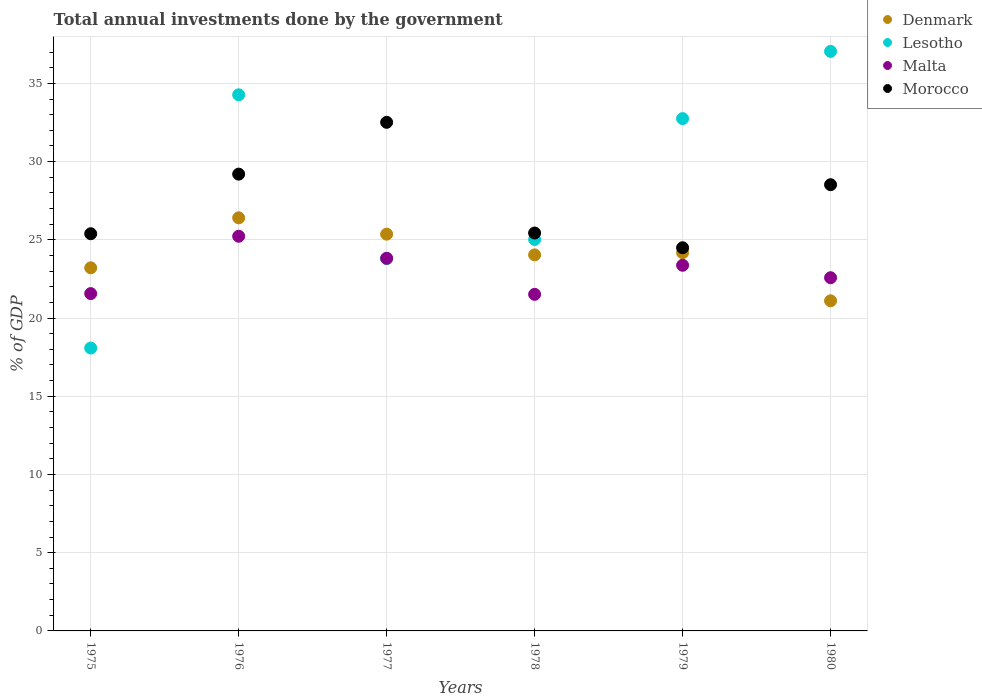What is the total annual investments done by the government in Malta in 1978?
Ensure brevity in your answer.  21.51. Across all years, what is the maximum total annual investments done by the government in Malta?
Provide a succinct answer. 25.23. Across all years, what is the minimum total annual investments done by the government in Malta?
Keep it short and to the point. 21.51. In which year was the total annual investments done by the government in Denmark maximum?
Your answer should be compact. 1976. In which year was the total annual investments done by the government in Lesotho minimum?
Your response must be concise. 1975. What is the total total annual investments done by the government in Morocco in the graph?
Ensure brevity in your answer.  165.54. What is the difference between the total annual investments done by the government in Malta in 1976 and that in 1980?
Ensure brevity in your answer.  2.65. What is the difference between the total annual investments done by the government in Lesotho in 1978 and the total annual investments done by the government in Morocco in 1976?
Give a very brief answer. -4.18. What is the average total annual investments done by the government in Lesotho per year?
Make the answer very short. 28.49. In the year 1978, what is the difference between the total annual investments done by the government in Denmark and total annual investments done by the government in Malta?
Provide a short and direct response. 2.52. What is the ratio of the total annual investments done by the government in Lesotho in 1975 to that in 1980?
Offer a terse response. 0.49. What is the difference between the highest and the second highest total annual investments done by the government in Morocco?
Provide a succinct answer. 3.31. What is the difference between the highest and the lowest total annual investments done by the government in Lesotho?
Provide a short and direct response. 18.96. Is the sum of the total annual investments done by the government in Malta in 1976 and 1979 greater than the maximum total annual investments done by the government in Lesotho across all years?
Your response must be concise. Yes. Is it the case that in every year, the sum of the total annual investments done by the government in Lesotho and total annual investments done by the government in Denmark  is greater than the total annual investments done by the government in Morocco?
Give a very brief answer. Yes. Does the total annual investments done by the government in Morocco monotonically increase over the years?
Give a very brief answer. No. Is the total annual investments done by the government in Lesotho strictly less than the total annual investments done by the government in Morocco over the years?
Ensure brevity in your answer.  No. How many dotlines are there?
Keep it short and to the point. 4. What is the difference between two consecutive major ticks on the Y-axis?
Ensure brevity in your answer.  5. Are the values on the major ticks of Y-axis written in scientific E-notation?
Ensure brevity in your answer.  No. Does the graph contain any zero values?
Your answer should be compact. No. Does the graph contain grids?
Your answer should be compact. Yes. How many legend labels are there?
Offer a very short reply. 4. What is the title of the graph?
Keep it short and to the point. Total annual investments done by the government. What is the label or title of the Y-axis?
Your response must be concise. % of GDP. What is the % of GDP of Denmark in 1975?
Provide a short and direct response. 23.21. What is the % of GDP of Lesotho in 1975?
Give a very brief answer. 18.08. What is the % of GDP of Malta in 1975?
Your response must be concise. 21.56. What is the % of GDP in Morocco in 1975?
Give a very brief answer. 25.39. What is the % of GDP of Denmark in 1976?
Offer a very short reply. 26.41. What is the % of GDP of Lesotho in 1976?
Provide a short and direct response. 34.27. What is the % of GDP in Malta in 1976?
Offer a terse response. 25.23. What is the % of GDP in Morocco in 1976?
Your response must be concise. 29.2. What is the % of GDP of Denmark in 1977?
Ensure brevity in your answer.  25.36. What is the % of GDP in Lesotho in 1977?
Offer a terse response. 23.8. What is the % of GDP in Malta in 1977?
Your response must be concise. 23.82. What is the % of GDP of Morocco in 1977?
Your response must be concise. 32.51. What is the % of GDP of Denmark in 1978?
Give a very brief answer. 24.04. What is the % of GDP of Lesotho in 1978?
Your answer should be compact. 25.02. What is the % of GDP of Malta in 1978?
Keep it short and to the point. 21.51. What is the % of GDP in Morocco in 1978?
Make the answer very short. 25.43. What is the % of GDP in Denmark in 1979?
Keep it short and to the point. 24.18. What is the % of GDP in Lesotho in 1979?
Make the answer very short. 32.75. What is the % of GDP of Malta in 1979?
Your answer should be compact. 23.37. What is the % of GDP of Morocco in 1979?
Offer a terse response. 24.49. What is the % of GDP in Denmark in 1980?
Keep it short and to the point. 21.1. What is the % of GDP in Lesotho in 1980?
Your answer should be compact. 37.04. What is the % of GDP of Malta in 1980?
Provide a short and direct response. 22.58. What is the % of GDP in Morocco in 1980?
Offer a terse response. 28.52. Across all years, what is the maximum % of GDP in Denmark?
Provide a succinct answer. 26.41. Across all years, what is the maximum % of GDP in Lesotho?
Your answer should be compact. 37.04. Across all years, what is the maximum % of GDP in Malta?
Keep it short and to the point. 25.23. Across all years, what is the maximum % of GDP in Morocco?
Your answer should be very brief. 32.51. Across all years, what is the minimum % of GDP of Denmark?
Offer a terse response. 21.1. Across all years, what is the minimum % of GDP of Lesotho?
Keep it short and to the point. 18.08. Across all years, what is the minimum % of GDP in Malta?
Keep it short and to the point. 21.51. Across all years, what is the minimum % of GDP of Morocco?
Keep it short and to the point. 24.49. What is the total % of GDP in Denmark in the graph?
Provide a succinct answer. 144.29. What is the total % of GDP in Lesotho in the graph?
Give a very brief answer. 170.96. What is the total % of GDP in Malta in the graph?
Your answer should be very brief. 138.07. What is the total % of GDP of Morocco in the graph?
Provide a succinct answer. 165.54. What is the difference between the % of GDP of Denmark in 1975 and that in 1976?
Ensure brevity in your answer.  -3.2. What is the difference between the % of GDP of Lesotho in 1975 and that in 1976?
Provide a short and direct response. -16.18. What is the difference between the % of GDP of Malta in 1975 and that in 1976?
Make the answer very short. -3.67. What is the difference between the % of GDP of Morocco in 1975 and that in 1976?
Your answer should be very brief. -3.81. What is the difference between the % of GDP of Denmark in 1975 and that in 1977?
Offer a terse response. -2.15. What is the difference between the % of GDP of Lesotho in 1975 and that in 1977?
Your answer should be compact. -5.71. What is the difference between the % of GDP in Malta in 1975 and that in 1977?
Ensure brevity in your answer.  -2.26. What is the difference between the % of GDP in Morocco in 1975 and that in 1977?
Keep it short and to the point. -7.12. What is the difference between the % of GDP in Denmark in 1975 and that in 1978?
Your response must be concise. -0.83. What is the difference between the % of GDP of Lesotho in 1975 and that in 1978?
Your answer should be very brief. -6.94. What is the difference between the % of GDP of Malta in 1975 and that in 1978?
Ensure brevity in your answer.  0.05. What is the difference between the % of GDP of Morocco in 1975 and that in 1978?
Your answer should be very brief. -0.05. What is the difference between the % of GDP of Denmark in 1975 and that in 1979?
Give a very brief answer. -0.97. What is the difference between the % of GDP of Lesotho in 1975 and that in 1979?
Your response must be concise. -14.66. What is the difference between the % of GDP in Malta in 1975 and that in 1979?
Offer a terse response. -1.81. What is the difference between the % of GDP in Morocco in 1975 and that in 1979?
Make the answer very short. 0.9. What is the difference between the % of GDP in Denmark in 1975 and that in 1980?
Offer a very short reply. 2.11. What is the difference between the % of GDP of Lesotho in 1975 and that in 1980?
Ensure brevity in your answer.  -18.96. What is the difference between the % of GDP in Malta in 1975 and that in 1980?
Offer a very short reply. -1.01. What is the difference between the % of GDP of Morocco in 1975 and that in 1980?
Provide a succinct answer. -3.13. What is the difference between the % of GDP in Denmark in 1976 and that in 1977?
Provide a short and direct response. 1.04. What is the difference between the % of GDP in Lesotho in 1976 and that in 1977?
Provide a short and direct response. 10.47. What is the difference between the % of GDP in Malta in 1976 and that in 1977?
Your answer should be very brief. 1.41. What is the difference between the % of GDP in Morocco in 1976 and that in 1977?
Provide a short and direct response. -3.31. What is the difference between the % of GDP of Denmark in 1976 and that in 1978?
Provide a short and direct response. 2.37. What is the difference between the % of GDP in Lesotho in 1976 and that in 1978?
Provide a succinct answer. 9.25. What is the difference between the % of GDP in Malta in 1976 and that in 1978?
Offer a very short reply. 3.71. What is the difference between the % of GDP in Morocco in 1976 and that in 1978?
Provide a short and direct response. 3.76. What is the difference between the % of GDP of Denmark in 1976 and that in 1979?
Make the answer very short. 2.23. What is the difference between the % of GDP in Lesotho in 1976 and that in 1979?
Give a very brief answer. 1.52. What is the difference between the % of GDP of Malta in 1976 and that in 1979?
Your answer should be compact. 1.86. What is the difference between the % of GDP of Morocco in 1976 and that in 1979?
Your response must be concise. 4.71. What is the difference between the % of GDP of Denmark in 1976 and that in 1980?
Make the answer very short. 5.3. What is the difference between the % of GDP in Lesotho in 1976 and that in 1980?
Keep it short and to the point. -2.77. What is the difference between the % of GDP in Malta in 1976 and that in 1980?
Give a very brief answer. 2.65. What is the difference between the % of GDP in Morocco in 1976 and that in 1980?
Your response must be concise. 0.68. What is the difference between the % of GDP of Denmark in 1977 and that in 1978?
Offer a very short reply. 1.33. What is the difference between the % of GDP in Lesotho in 1977 and that in 1978?
Make the answer very short. -1.23. What is the difference between the % of GDP in Malta in 1977 and that in 1978?
Ensure brevity in your answer.  2.31. What is the difference between the % of GDP in Morocco in 1977 and that in 1978?
Your answer should be compact. 7.08. What is the difference between the % of GDP of Denmark in 1977 and that in 1979?
Offer a very short reply. 1.19. What is the difference between the % of GDP of Lesotho in 1977 and that in 1979?
Make the answer very short. -8.95. What is the difference between the % of GDP of Malta in 1977 and that in 1979?
Your response must be concise. 0.45. What is the difference between the % of GDP of Morocco in 1977 and that in 1979?
Your answer should be very brief. 8.02. What is the difference between the % of GDP in Denmark in 1977 and that in 1980?
Offer a terse response. 4.26. What is the difference between the % of GDP of Lesotho in 1977 and that in 1980?
Your answer should be very brief. -13.25. What is the difference between the % of GDP in Malta in 1977 and that in 1980?
Provide a succinct answer. 1.24. What is the difference between the % of GDP of Morocco in 1977 and that in 1980?
Give a very brief answer. 3.99. What is the difference between the % of GDP in Denmark in 1978 and that in 1979?
Your response must be concise. -0.14. What is the difference between the % of GDP in Lesotho in 1978 and that in 1979?
Offer a terse response. -7.73. What is the difference between the % of GDP of Malta in 1978 and that in 1979?
Offer a very short reply. -1.86. What is the difference between the % of GDP in Morocco in 1978 and that in 1979?
Ensure brevity in your answer.  0.94. What is the difference between the % of GDP in Denmark in 1978 and that in 1980?
Your answer should be very brief. 2.94. What is the difference between the % of GDP of Lesotho in 1978 and that in 1980?
Your answer should be compact. -12.02. What is the difference between the % of GDP of Malta in 1978 and that in 1980?
Your response must be concise. -1.06. What is the difference between the % of GDP in Morocco in 1978 and that in 1980?
Provide a short and direct response. -3.09. What is the difference between the % of GDP in Denmark in 1979 and that in 1980?
Your answer should be compact. 3.08. What is the difference between the % of GDP of Lesotho in 1979 and that in 1980?
Your response must be concise. -4.3. What is the difference between the % of GDP in Malta in 1979 and that in 1980?
Your response must be concise. 0.79. What is the difference between the % of GDP in Morocco in 1979 and that in 1980?
Make the answer very short. -4.03. What is the difference between the % of GDP of Denmark in 1975 and the % of GDP of Lesotho in 1976?
Give a very brief answer. -11.06. What is the difference between the % of GDP of Denmark in 1975 and the % of GDP of Malta in 1976?
Offer a very short reply. -2.02. What is the difference between the % of GDP in Denmark in 1975 and the % of GDP in Morocco in 1976?
Ensure brevity in your answer.  -5.99. What is the difference between the % of GDP in Lesotho in 1975 and the % of GDP in Malta in 1976?
Your response must be concise. -7.14. What is the difference between the % of GDP of Lesotho in 1975 and the % of GDP of Morocco in 1976?
Your answer should be very brief. -11.11. What is the difference between the % of GDP in Malta in 1975 and the % of GDP in Morocco in 1976?
Your answer should be very brief. -7.64. What is the difference between the % of GDP in Denmark in 1975 and the % of GDP in Lesotho in 1977?
Provide a succinct answer. -0.59. What is the difference between the % of GDP in Denmark in 1975 and the % of GDP in Malta in 1977?
Ensure brevity in your answer.  -0.61. What is the difference between the % of GDP of Denmark in 1975 and the % of GDP of Morocco in 1977?
Your answer should be compact. -9.3. What is the difference between the % of GDP in Lesotho in 1975 and the % of GDP in Malta in 1977?
Give a very brief answer. -5.74. What is the difference between the % of GDP of Lesotho in 1975 and the % of GDP of Morocco in 1977?
Provide a short and direct response. -14.43. What is the difference between the % of GDP in Malta in 1975 and the % of GDP in Morocco in 1977?
Ensure brevity in your answer.  -10.95. What is the difference between the % of GDP of Denmark in 1975 and the % of GDP of Lesotho in 1978?
Provide a short and direct response. -1.81. What is the difference between the % of GDP of Denmark in 1975 and the % of GDP of Malta in 1978?
Provide a succinct answer. 1.69. What is the difference between the % of GDP in Denmark in 1975 and the % of GDP in Morocco in 1978?
Give a very brief answer. -2.22. What is the difference between the % of GDP of Lesotho in 1975 and the % of GDP of Malta in 1978?
Give a very brief answer. -3.43. What is the difference between the % of GDP in Lesotho in 1975 and the % of GDP in Morocco in 1978?
Provide a succinct answer. -7.35. What is the difference between the % of GDP of Malta in 1975 and the % of GDP of Morocco in 1978?
Provide a short and direct response. -3.87. What is the difference between the % of GDP of Denmark in 1975 and the % of GDP of Lesotho in 1979?
Your answer should be compact. -9.54. What is the difference between the % of GDP of Denmark in 1975 and the % of GDP of Malta in 1979?
Your answer should be very brief. -0.16. What is the difference between the % of GDP in Denmark in 1975 and the % of GDP in Morocco in 1979?
Give a very brief answer. -1.28. What is the difference between the % of GDP in Lesotho in 1975 and the % of GDP in Malta in 1979?
Make the answer very short. -5.29. What is the difference between the % of GDP of Lesotho in 1975 and the % of GDP of Morocco in 1979?
Offer a terse response. -6.41. What is the difference between the % of GDP of Malta in 1975 and the % of GDP of Morocco in 1979?
Your response must be concise. -2.93. What is the difference between the % of GDP in Denmark in 1975 and the % of GDP in Lesotho in 1980?
Your response must be concise. -13.83. What is the difference between the % of GDP of Denmark in 1975 and the % of GDP of Malta in 1980?
Keep it short and to the point. 0.63. What is the difference between the % of GDP in Denmark in 1975 and the % of GDP in Morocco in 1980?
Offer a very short reply. -5.31. What is the difference between the % of GDP of Lesotho in 1975 and the % of GDP of Malta in 1980?
Your answer should be very brief. -4.49. What is the difference between the % of GDP of Lesotho in 1975 and the % of GDP of Morocco in 1980?
Make the answer very short. -10.44. What is the difference between the % of GDP in Malta in 1975 and the % of GDP in Morocco in 1980?
Your answer should be compact. -6.96. What is the difference between the % of GDP in Denmark in 1976 and the % of GDP in Lesotho in 1977?
Provide a succinct answer. 2.61. What is the difference between the % of GDP in Denmark in 1976 and the % of GDP in Malta in 1977?
Your response must be concise. 2.59. What is the difference between the % of GDP in Denmark in 1976 and the % of GDP in Morocco in 1977?
Provide a succinct answer. -6.1. What is the difference between the % of GDP in Lesotho in 1976 and the % of GDP in Malta in 1977?
Your response must be concise. 10.45. What is the difference between the % of GDP of Lesotho in 1976 and the % of GDP of Morocco in 1977?
Provide a succinct answer. 1.76. What is the difference between the % of GDP of Malta in 1976 and the % of GDP of Morocco in 1977?
Ensure brevity in your answer.  -7.28. What is the difference between the % of GDP of Denmark in 1976 and the % of GDP of Lesotho in 1978?
Your answer should be compact. 1.38. What is the difference between the % of GDP in Denmark in 1976 and the % of GDP in Malta in 1978?
Your answer should be very brief. 4.89. What is the difference between the % of GDP of Denmark in 1976 and the % of GDP of Morocco in 1978?
Offer a very short reply. 0.97. What is the difference between the % of GDP in Lesotho in 1976 and the % of GDP in Malta in 1978?
Offer a very short reply. 12.75. What is the difference between the % of GDP of Lesotho in 1976 and the % of GDP of Morocco in 1978?
Keep it short and to the point. 8.83. What is the difference between the % of GDP in Malta in 1976 and the % of GDP in Morocco in 1978?
Provide a succinct answer. -0.21. What is the difference between the % of GDP of Denmark in 1976 and the % of GDP of Lesotho in 1979?
Keep it short and to the point. -6.34. What is the difference between the % of GDP in Denmark in 1976 and the % of GDP in Malta in 1979?
Provide a short and direct response. 3.03. What is the difference between the % of GDP of Denmark in 1976 and the % of GDP of Morocco in 1979?
Provide a short and direct response. 1.91. What is the difference between the % of GDP in Lesotho in 1976 and the % of GDP in Malta in 1979?
Your response must be concise. 10.9. What is the difference between the % of GDP of Lesotho in 1976 and the % of GDP of Morocco in 1979?
Your answer should be compact. 9.78. What is the difference between the % of GDP of Malta in 1976 and the % of GDP of Morocco in 1979?
Offer a terse response. 0.74. What is the difference between the % of GDP in Denmark in 1976 and the % of GDP in Lesotho in 1980?
Provide a succinct answer. -10.64. What is the difference between the % of GDP of Denmark in 1976 and the % of GDP of Malta in 1980?
Your response must be concise. 3.83. What is the difference between the % of GDP in Denmark in 1976 and the % of GDP in Morocco in 1980?
Provide a succinct answer. -2.12. What is the difference between the % of GDP of Lesotho in 1976 and the % of GDP of Malta in 1980?
Provide a succinct answer. 11.69. What is the difference between the % of GDP of Lesotho in 1976 and the % of GDP of Morocco in 1980?
Make the answer very short. 5.75. What is the difference between the % of GDP in Malta in 1976 and the % of GDP in Morocco in 1980?
Provide a short and direct response. -3.29. What is the difference between the % of GDP of Denmark in 1977 and the % of GDP of Lesotho in 1978?
Your answer should be very brief. 0.34. What is the difference between the % of GDP in Denmark in 1977 and the % of GDP in Malta in 1978?
Keep it short and to the point. 3.85. What is the difference between the % of GDP of Denmark in 1977 and the % of GDP of Morocco in 1978?
Ensure brevity in your answer.  -0.07. What is the difference between the % of GDP of Lesotho in 1977 and the % of GDP of Malta in 1978?
Your answer should be very brief. 2.28. What is the difference between the % of GDP in Lesotho in 1977 and the % of GDP in Morocco in 1978?
Your answer should be compact. -1.64. What is the difference between the % of GDP in Malta in 1977 and the % of GDP in Morocco in 1978?
Offer a terse response. -1.61. What is the difference between the % of GDP of Denmark in 1977 and the % of GDP of Lesotho in 1979?
Your response must be concise. -7.38. What is the difference between the % of GDP in Denmark in 1977 and the % of GDP in Malta in 1979?
Give a very brief answer. 1.99. What is the difference between the % of GDP of Denmark in 1977 and the % of GDP of Morocco in 1979?
Give a very brief answer. 0.87. What is the difference between the % of GDP in Lesotho in 1977 and the % of GDP in Malta in 1979?
Make the answer very short. 0.42. What is the difference between the % of GDP of Lesotho in 1977 and the % of GDP of Morocco in 1979?
Provide a succinct answer. -0.7. What is the difference between the % of GDP in Malta in 1977 and the % of GDP in Morocco in 1979?
Keep it short and to the point. -0.67. What is the difference between the % of GDP of Denmark in 1977 and the % of GDP of Lesotho in 1980?
Offer a terse response. -11.68. What is the difference between the % of GDP of Denmark in 1977 and the % of GDP of Malta in 1980?
Provide a succinct answer. 2.79. What is the difference between the % of GDP of Denmark in 1977 and the % of GDP of Morocco in 1980?
Your response must be concise. -3.16. What is the difference between the % of GDP of Lesotho in 1977 and the % of GDP of Malta in 1980?
Offer a terse response. 1.22. What is the difference between the % of GDP of Lesotho in 1977 and the % of GDP of Morocco in 1980?
Provide a short and direct response. -4.73. What is the difference between the % of GDP of Malta in 1977 and the % of GDP of Morocco in 1980?
Your answer should be very brief. -4.7. What is the difference between the % of GDP in Denmark in 1978 and the % of GDP in Lesotho in 1979?
Keep it short and to the point. -8.71. What is the difference between the % of GDP of Denmark in 1978 and the % of GDP of Malta in 1979?
Provide a short and direct response. 0.66. What is the difference between the % of GDP in Denmark in 1978 and the % of GDP in Morocco in 1979?
Provide a short and direct response. -0.46. What is the difference between the % of GDP in Lesotho in 1978 and the % of GDP in Malta in 1979?
Ensure brevity in your answer.  1.65. What is the difference between the % of GDP of Lesotho in 1978 and the % of GDP of Morocco in 1979?
Your answer should be compact. 0.53. What is the difference between the % of GDP in Malta in 1978 and the % of GDP in Morocco in 1979?
Your answer should be compact. -2.98. What is the difference between the % of GDP in Denmark in 1978 and the % of GDP in Lesotho in 1980?
Give a very brief answer. -13.01. What is the difference between the % of GDP of Denmark in 1978 and the % of GDP of Malta in 1980?
Your answer should be compact. 1.46. What is the difference between the % of GDP in Denmark in 1978 and the % of GDP in Morocco in 1980?
Offer a very short reply. -4.49. What is the difference between the % of GDP of Lesotho in 1978 and the % of GDP of Malta in 1980?
Provide a succinct answer. 2.44. What is the difference between the % of GDP in Lesotho in 1978 and the % of GDP in Morocco in 1980?
Your answer should be compact. -3.5. What is the difference between the % of GDP of Malta in 1978 and the % of GDP of Morocco in 1980?
Make the answer very short. -7.01. What is the difference between the % of GDP of Denmark in 1979 and the % of GDP of Lesotho in 1980?
Your answer should be compact. -12.87. What is the difference between the % of GDP of Denmark in 1979 and the % of GDP of Malta in 1980?
Make the answer very short. 1.6. What is the difference between the % of GDP in Denmark in 1979 and the % of GDP in Morocco in 1980?
Your answer should be very brief. -4.35. What is the difference between the % of GDP of Lesotho in 1979 and the % of GDP of Malta in 1980?
Provide a short and direct response. 10.17. What is the difference between the % of GDP of Lesotho in 1979 and the % of GDP of Morocco in 1980?
Your response must be concise. 4.22. What is the difference between the % of GDP in Malta in 1979 and the % of GDP in Morocco in 1980?
Keep it short and to the point. -5.15. What is the average % of GDP in Denmark per year?
Keep it short and to the point. 24.05. What is the average % of GDP of Lesotho per year?
Your answer should be very brief. 28.49. What is the average % of GDP in Malta per year?
Offer a very short reply. 23.01. What is the average % of GDP in Morocco per year?
Make the answer very short. 27.59. In the year 1975, what is the difference between the % of GDP of Denmark and % of GDP of Lesotho?
Your response must be concise. 5.13. In the year 1975, what is the difference between the % of GDP of Denmark and % of GDP of Malta?
Ensure brevity in your answer.  1.65. In the year 1975, what is the difference between the % of GDP in Denmark and % of GDP in Morocco?
Provide a short and direct response. -2.18. In the year 1975, what is the difference between the % of GDP of Lesotho and % of GDP of Malta?
Make the answer very short. -3.48. In the year 1975, what is the difference between the % of GDP in Lesotho and % of GDP in Morocco?
Offer a terse response. -7.3. In the year 1975, what is the difference between the % of GDP of Malta and % of GDP of Morocco?
Provide a succinct answer. -3.83. In the year 1976, what is the difference between the % of GDP in Denmark and % of GDP in Lesotho?
Ensure brevity in your answer.  -7.86. In the year 1976, what is the difference between the % of GDP of Denmark and % of GDP of Malta?
Offer a terse response. 1.18. In the year 1976, what is the difference between the % of GDP of Denmark and % of GDP of Morocco?
Your answer should be compact. -2.79. In the year 1976, what is the difference between the % of GDP of Lesotho and % of GDP of Malta?
Provide a short and direct response. 9.04. In the year 1976, what is the difference between the % of GDP of Lesotho and % of GDP of Morocco?
Give a very brief answer. 5.07. In the year 1976, what is the difference between the % of GDP in Malta and % of GDP in Morocco?
Your response must be concise. -3.97. In the year 1977, what is the difference between the % of GDP in Denmark and % of GDP in Lesotho?
Provide a succinct answer. 1.57. In the year 1977, what is the difference between the % of GDP of Denmark and % of GDP of Malta?
Provide a succinct answer. 1.54. In the year 1977, what is the difference between the % of GDP in Denmark and % of GDP in Morocco?
Your answer should be very brief. -7.15. In the year 1977, what is the difference between the % of GDP of Lesotho and % of GDP of Malta?
Your response must be concise. -0.02. In the year 1977, what is the difference between the % of GDP of Lesotho and % of GDP of Morocco?
Your answer should be very brief. -8.71. In the year 1977, what is the difference between the % of GDP of Malta and % of GDP of Morocco?
Your answer should be very brief. -8.69. In the year 1978, what is the difference between the % of GDP of Denmark and % of GDP of Lesotho?
Your answer should be very brief. -0.99. In the year 1978, what is the difference between the % of GDP of Denmark and % of GDP of Malta?
Ensure brevity in your answer.  2.52. In the year 1978, what is the difference between the % of GDP of Denmark and % of GDP of Morocco?
Give a very brief answer. -1.4. In the year 1978, what is the difference between the % of GDP in Lesotho and % of GDP in Malta?
Provide a short and direct response. 3.51. In the year 1978, what is the difference between the % of GDP in Lesotho and % of GDP in Morocco?
Provide a succinct answer. -0.41. In the year 1978, what is the difference between the % of GDP in Malta and % of GDP in Morocco?
Ensure brevity in your answer.  -3.92. In the year 1979, what is the difference between the % of GDP of Denmark and % of GDP of Lesotho?
Make the answer very short. -8.57. In the year 1979, what is the difference between the % of GDP in Denmark and % of GDP in Malta?
Keep it short and to the point. 0.8. In the year 1979, what is the difference between the % of GDP of Denmark and % of GDP of Morocco?
Provide a succinct answer. -0.32. In the year 1979, what is the difference between the % of GDP in Lesotho and % of GDP in Malta?
Offer a very short reply. 9.38. In the year 1979, what is the difference between the % of GDP in Lesotho and % of GDP in Morocco?
Provide a succinct answer. 8.25. In the year 1979, what is the difference between the % of GDP of Malta and % of GDP of Morocco?
Offer a terse response. -1.12. In the year 1980, what is the difference between the % of GDP in Denmark and % of GDP in Lesotho?
Offer a terse response. -15.94. In the year 1980, what is the difference between the % of GDP of Denmark and % of GDP of Malta?
Offer a terse response. -1.48. In the year 1980, what is the difference between the % of GDP of Denmark and % of GDP of Morocco?
Keep it short and to the point. -7.42. In the year 1980, what is the difference between the % of GDP in Lesotho and % of GDP in Malta?
Your response must be concise. 14.47. In the year 1980, what is the difference between the % of GDP of Lesotho and % of GDP of Morocco?
Ensure brevity in your answer.  8.52. In the year 1980, what is the difference between the % of GDP of Malta and % of GDP of Morocco?
Your answer should be compact. -5.95. What is the ratio of the % of GDP in Denmark in 1975 to that in 1976?
Ensure brevity in your answer.  0.88. What is the ratio of the % of GDP of Lesotho in 1975 to that in 1976?
Provide a succinct answer. 0.53. What is the ratio of the % of GDP of Malta in 1975 to that in 1976?
Your answer should be compact. 0.85. What is the ratio of the % of GDP in Morocco in 1975 to that in 1976?
Your response must be concise. 0.87. What is the ratio of the % of GDP of Denmark in 1975 to that in 1977?
Keep it short and to the point. 0.92. What is the ratio of the % of GDP in Lesotho in 1975 to that in 1977?
Ensure brevity in your answer.  0.76. What is the ratio of the % of GDP of Malta in 1975 to that in 1977?
Make the answer very short. 0.91. What is the ratio of the % of GDP in Morocco in 1975 to that in 1977?
Your response must be concise. 0.78. What is the ratio of the % of GDP of Denmark in 1975 to that in 1978?
Offer a very short reply. 0.97. What is the ratio of the % of GDP of Lesotho in 1975 to that in 1978?
Provide a succinct answer. 0.72. What is the ratio of the % of GDP in Morocco in 1975 to that in 1978?
Give a very brief answer. 1. What is the ratio of the % of GDP in Denmark in 1975 to that in 1979?
Ensure brevity in your answer.  0.96. What is the ratio of the % of GDP in Lesotho in 1975 to that in 1979?
Ensure brevity in your answer.  0.55. What is the ratio of the % of GDP of Malta in 1975 to that in 1979?
Provide a succinct answer. 0.92. What is the ratio of the % of GDP in Morocco in 1975 to that in 1979?
Your answer should be compact. 1.04. What is the ratio of the % of GDP in Denmark in 1975 to that in 1980?
Offer a very short reply. 1.1. What is the ratio of the % of GDP in Lesotho in 1975 to that in 1980?
Your answer should be compact. 0.49. What is the ratio of the % of GDP in Malta in 1975 to that in 1980?
Provide a succinct answer. 0.95. What is the ratio of the % of GDP of Morocco in 1975 to that in 1980?
Keep it short and to the point. 0.89. What is the ratio of the % of GDP of Denmark in 1976 to that in 1977?
Your response must be concise. 1.04. What is the ratio of the % of GDP of Lesotho in 1976 to that in 1977?
Offer a terse response. 1.44. What is the ratio of the % of GDP in Malta in 1976 to that in 1977?
Provide a short and direct response. 1.06. What is the ratio of the % of GDP of Morocco in 1976 to that in 1977?
Provide a succinct answer. 0.9. What is the ratio of the % of GDP in Denmark in 1976 to that in 1978?
Provide a succinct answer. 1.1. What is the ratio of the % of GDP of Lesotho in 1976 to that in 1978?
Your answer should be very brief. 1.37. What is the ratio of the % of GDP of Malta in 1976 to that in 1978?
Provide a succinct answer. 1.17. What is the ratio of the % of GDP in Morocco in 1976 to that in 1978?
Provide a succinct answer. 1.15. What is the ratio of the % of GDP of Denmark in 1976 to that in 1979?
Offer a very short reply. 1.09. What is the ratio of the % of GDP in Lesotho in 1976 to that in 1979?
Your answer should be compact. 1.05. What is the ratio of the % of GDP in Malta in 1976 to that in 1979?
Ensure brevity in your answer.  1.08. What is the ratio of the % of GDP in Morocco in 1976 to that in 1979?
Your answer should be very brief. 1.19. What is the ratio of the % of GDP in Denmark in 1976 to that in 1980?
Your answer should be very brief. 1.25. What is the ratio of the % of GDP of Lesotho in 1976 to that in 1980?
Your answer should be compact. 0.93. What is the ratio of the % of GDP of Malta in 1976 to that in 1980?
Keep it short and to the point. 1.12. What is the ratio of the % of GDP of Morocco in 1976 to that in 1980?
Provide a short and direct response. 1.02. What is the ratio of the % of GDP of Denmark in 1977 to that in 1978?
Your response must be concise. 1.06. What is the ratio of the % of GDP of Lesotho in 1977 to that in 1978?
Your answer should be compact. 0.95. What is the ratio of the % of GDP in Malta in 1977 to that in 1978?
Your answer should be very brief. 1.11. What is the ratio of the % of GDP of Morocco in 1977 to that in 1978?
Your response must be concise. 1.28. What is the ratio of the % of GDP in Denmark in 1977 to that in 1979?
Make the answer very short. 1.05. What is the ratio of the % of GDP in Lesotho in 1977 to that in 1979?
Your response must be concise. 0.73. What is the ratio of the % of GDP of Malta in 1977 to that in 1979?
Offer a very short reply. 1.02. What is the ratio of the % of GDP of Morocco in 1977 to that in 1979?
Provide a short and direct response. 1.33. What is the ratio of the % of GDP of Denmark in 1977 to that in 1980?
Give a very brief answer. 1.2. What is the ratio of the % of GDP of Lesotho in 1977 to that in 1980?
Your response must be concise. 0.64. What is the ratio of the % of GDP in Malta in 1977 to that in 1980?
Provide a short and direct response. 1.06. What is the ratio of the % of GDP in Morocco in 1977 to that in 1980?
Provide a short and direct response. 1.14. What is the ratio of the % of GDP in Denmark in 1978 to that in 1979?
Ensure brevity in your answer.  0.99. What is the ratio of the % of GDP in Lesotho in 1978 to that in 1979?
Offer a terse response. 0.76. What is the ratio of the % of GDP in Malta in 1978 to that in 1979?
Keep it short and to the point. 0.92. What is the ratio of the % of GDP in Morocco in 1978 to that in 1979?
Give a very brief answer. 1.04. What is the ratio of the % of GDP in Denmark in 1978 to that in 1980?
Give a very brief answer. 1.14. What is the ratio of the % of GDP of Lesotho in 1978 to that in 1980?
Your response must be concise. 0.68. What is the ratio of the % of GDP in Malta in 1978 to that in 1980?
Make the answer very short. 0.95. What is the ratio of the % of GDP in Morocco in 1978 to that in 1980?
Offer a very short reply. 0.89. What is the ratio of the % of GDP in Denmark in 1979 to that in 1980?
Offer a terse response. 1.15. What is the ratio of the % of GDP in Lesotho in 1979 to that in 1980?
Keep it short and to the point. 0.88. What is the ratio of the % of GDP of Malta in 1979 to that in 1980?
Your answer should be compact. 1.04. What is the ratio of the % of GDP in Morocco in 1979 to that in 1980?
Your answer should be compact. 0.86. What is the difference between the highest and the second highest % of GDP of Denmark?
Ensure brevity in your answer.  1.04. What is the difference between the highest and the second highest % of GDP of Lesotho?
Provide a succinct answer. 2.77. What is the difference between the highest and the second highest % of GDP of Malta?
Keep it short and to the point. 1.41. What is the difference between the highest and the second highest % of GDP in Morocco?
Offer a very short reply. 3.31. What is the difference between the highest and the lowest % of GDP in Denmark?
Provide a short and direct response. 5.3. What is the difference between the highest and the lowest % of GDP of Lesotho?
Your answer should be very brief. 18.96. What is the difference between the highest and the lowest % of GDP of Malta?
Make the answer very short. 3.71. What is the difference between the highest and the lowest % of GDP in Morocco?
Your response must be concise. 8.02. 